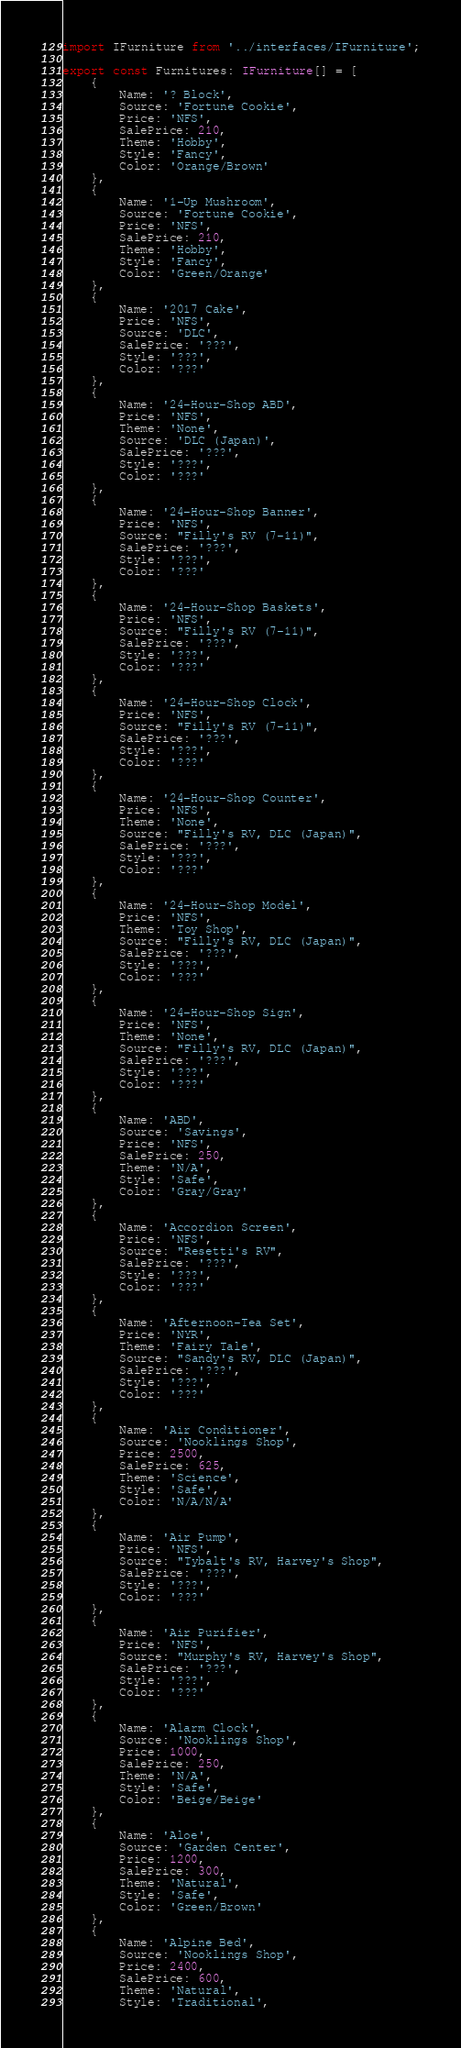<code> <loc_0><loc_0><loc_500><loc_500><_TypeScript_>import IFurniture from '../interfaces/IFurniture';

export const Furnitures: IFurniture[] = [
	{
		Name: '? Block',
		Source: 'Fortune Cookie',
		Price: 'NFS',
		SalePrice: 210,
		Theme: 'Hobby',
		Style: 'Fancy',
		Color: 'Orange/Brown'
	},
	{
		Name: '1-Up Mushroom',
		Source: 'Fortune Cookie',
		Price: 'NFS',
		SalePrice: 210,
		Theme: 'Hobby',
		Style: 'Fancy',
		Color: 'Green/Orange'
	},
	{
		Name: '2017 Cake',
		Price: 'NFS',
		Source: 'DLC',
		SalePrice: '???',
		Style: '???',
		Color: '???'
	},
	{
		Name: '24-Hour-Shop ABD',
		Price: 'NFS',
		Theme: 'None',
		Source: 'DLC (Japan)',
		SalePrice: '???',
		Style: '???',
		Color: '???'
	},
	{
		Name: '24-Hour-Shop Banner',
		Price: 'NFS',
		Source: "Filly's RV (7-11)",
		SalePrice: '???',
		Style: '???',
		Color: '???'
	},
	{
		Name: '24-Hour-Shop Baskets',
		Price: 'NFS',
		Source: "Filly's RV (7-11)",
		SalePrice: '???',
		Style: '???',
		Color: '???'
	},
	{
		Name: '24-Hour-Shop Clock',
		Price: 'NFS',
		Source: "Filly's RV (7-11)",
		SalePrice: '???',
		Style: '???',
		Color: '???'
	},
	{
		Name: '24-Hour-Shop Counter',
		Price: 'NFS',
		Theme: 'None',
		Source: "Filly's RV, DLC (Japan)",
		SalePrice: '???',
		Style: '???',
		Color: '???'
	},
	{
		Name: '24-Hour-Shop Model',
		Price: 'NFS',
		Theme: 'Toy Shop',
		Source: "Filly's RV, DLC (Japan)",
		SalePrice: '???',
		Style: '???',
		Color: '???'
	},
	{
		Name: '24-Hour-Shop Sign',
		Price: 'NFS',
		Theme: 'None',
		Source: "Filly's RV, DLC (Japan)",
		SalePrice: '???',
		Style: '???',
		Color: '???'
	},
	{
		Name: 'ABD',
		Source: 'Savings',
		Price: 'NFS',
		SalePrice: 250,
		Theme: 'N/A',
		Style: 'Safe',
		Color: 'Gray/Gray'
	},
	{
		Name: 'Accordion Screen',
		Price: 'NFS',
		Source: "Resetti's RV",
		SalePrice: '???',
		Style: '???',
		Color: '???'
	},
	{
		Name: 'Afternoon-Tea Set',
		Price: 'NYR',
		Theme: 'Fairy Tale',
		Source: "Sandy's RV, DLC (Japan)",
		SalePrice: '???',
		Style: '???',
		Color: '???'
	},
	{
		Name: 'Air Conditioner',
		Source: 'Nooklings Shop',
		Price: 2500,
		SalePrice: 625,
		Theme: 'Science',
		Style: 'Safe',
		Color: 'N/A/N/A'
	},
	{
		Name: 'Air Pump',
		Price: 'NFS',
		Source: "Tybalt's RV, Harvey's Shop",
		SalePrice: '???',
		Style: '???',
		Color: '???'
	},
	{
		Name: 'Air Purifier',
		Price: 'NFS',
		Source: "Murphy's RV, Harvey's Shop",
		SalePrice: '???',
		Style: '???',
		Color: '???'
	},
	{
		Name: 'Alarm Clock',
		Source: 'Nooklings Shop',
		Price: 1000,
		SalePrice: 250,
		Theme: 'N/A',
		Style: 'Safe',
		Color: 'Beige/Beige'
	},
	{
		Name: 'Aloe',
		Source: 'Garden Center',
		Price: 1200,
		SalePrice: 300,
		Theme: 'Natural',
		Style: 'Safe',
		Color: 'Green/Brown'
	},
	{
		Name: 'Alpine Bed',
		Source: 'Nooklings Shop',
		Price: 2400,
		SalePrice: 600,
		Theme: 'Natural',
		Style: 'Traditional',</code> 